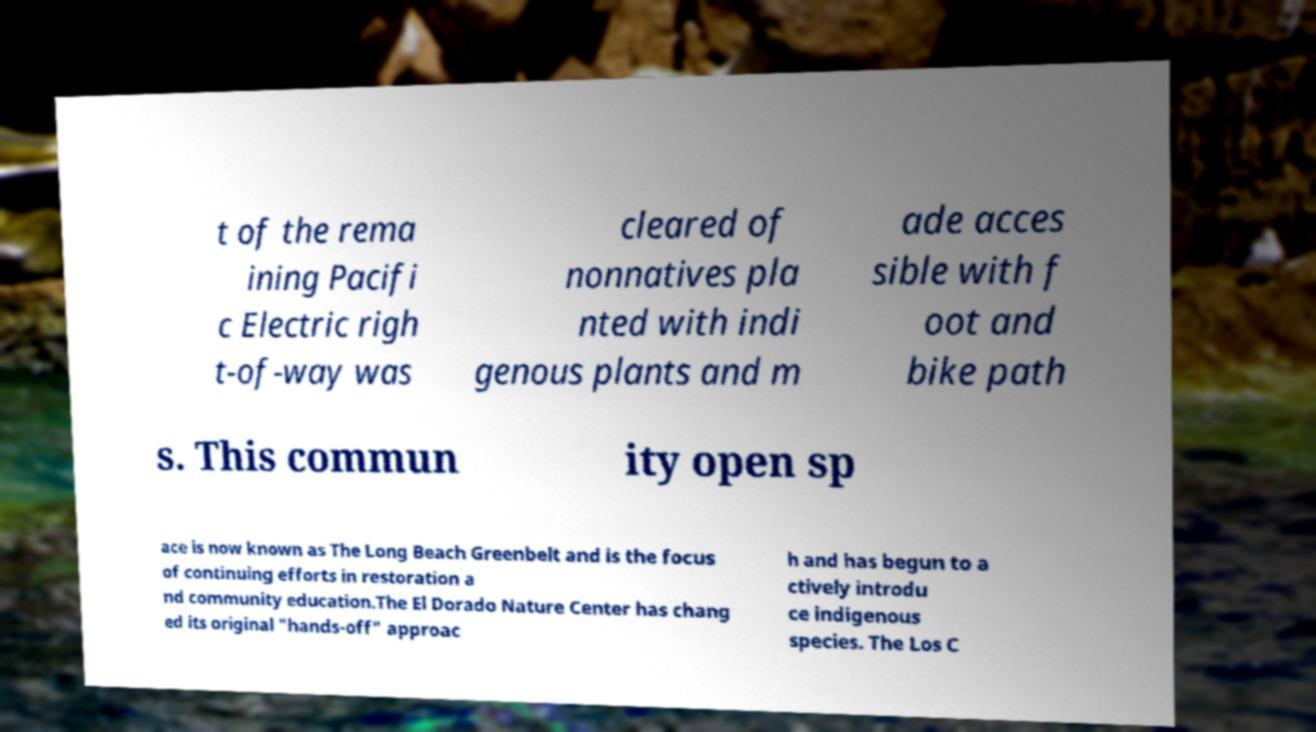Can you read and provide the text displayed in the image?This photo seems to have some interesting text. Can you extract and type it out for me? t of the rema ining Pacifi c Electric righ t-of-way was cleared of nonnatives pla nted with indi genous plants and m ade acces sible with f oot and bike path s. This commun ity open sp ace is now known as The Long Beach Greenbelt and is the focus of continuing efforts in restoration a nd community education.The El Dorado Nature Center has chang ed its original "hands-off" approac h and has begun to a ctively introdu ce indigenous species. The Los C 